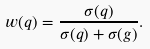Convert formula to latex. <formula><loc_0><loc_0><loc_500><loc_500>w ( q ) = \frac { \sigma ( q ) } { \sigma ( q ) + \sigma ( g ) } .</formula> 